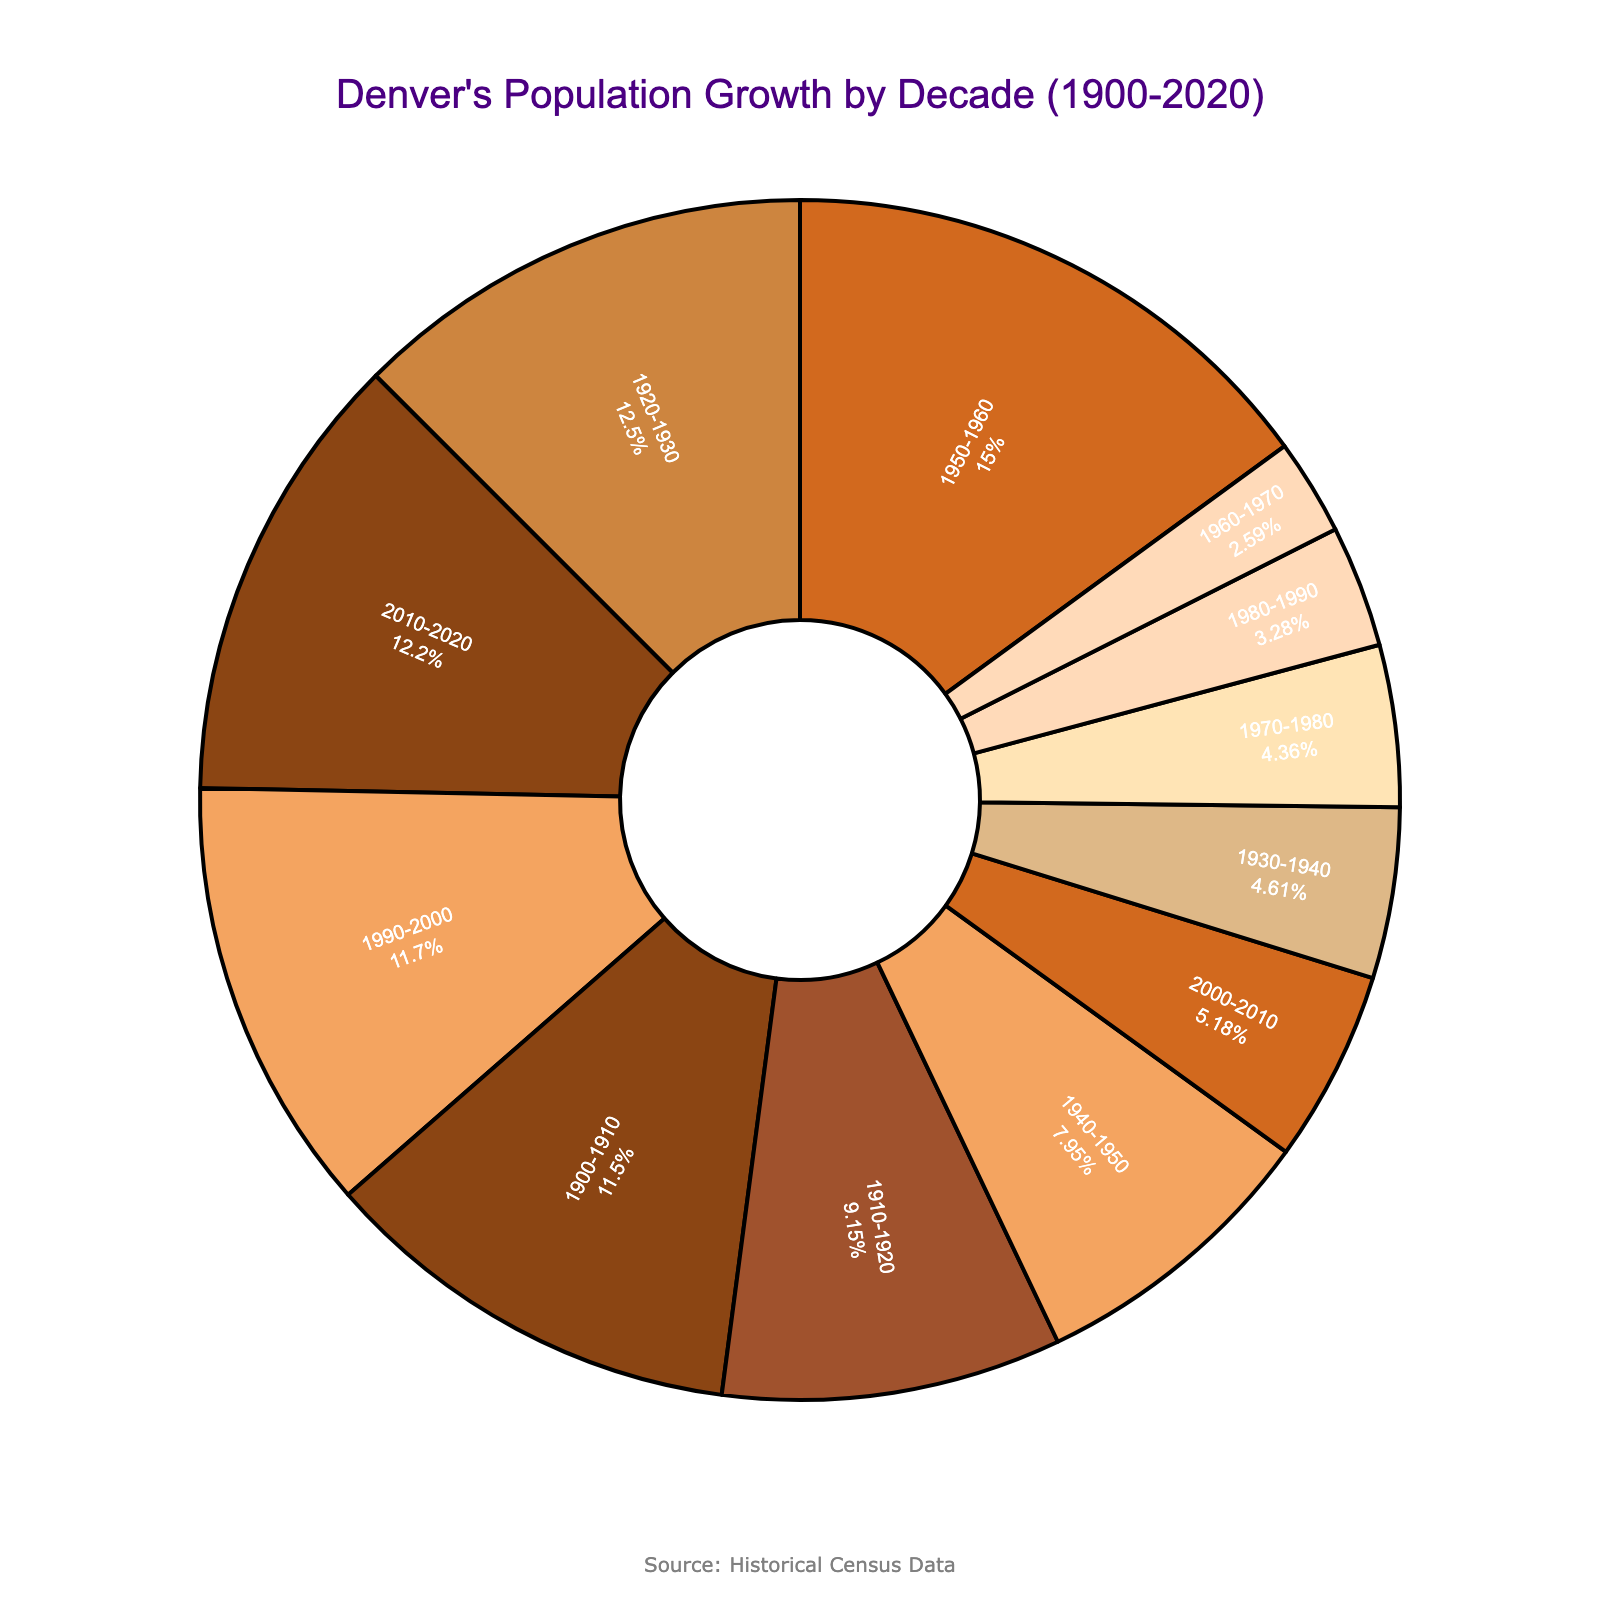Which decade had the highest percentage growth? Locate the segment with the highest percentage label; it's 1950-1960 with 23.7%.
Answer: 1950-1960 Which decade had a percentage decrease in population growth? Identify the segment with a negative percentage label; it's 1980-1990 with -5.2%.
Answer: 1980-1990 What is the combined percentage growth for the decades 1900-1910 and 2010-2020? Sum the percentages for these decades: 18.2% + 19.3% = 37.5%.
Answer: 37.5% Which two decades had percentage growths less than 10%? Identify segments with percentages below 10%; they are 1930-1940 (7.3%) and 1960-1970 (4.1%).
Answer: 1930-1940 and 1960-1970 Compare the percentage growth between 1920-1930 and 1940-1950? Subtract the percentage of 1940-1950 from 1920-1930: 19.8% - 12.6% = 7.2%.
Answer: 7.2% How many decades had growth percentages greater than 15%? Count the segments with percentages above 15%: 1900-1910, 1920-1930, 1950-1960, 1990-2000, and 2010-2020 (5 decades).
Answer: 5 Which decade has the smallest visual segment excluding the negative percentage? The smallest segment excluding the negative percentage is 1960-1970 with 4.1%.
Answer: 1960-1970 What is the average growth percentage for the decades from 2000 onwards? Calculate the average for 2000-2010 (8.2%) and 2010-2020 (19.3%): (8.2% + 19.3%) / 2 = 13.75%.
Answer: 13.75% 